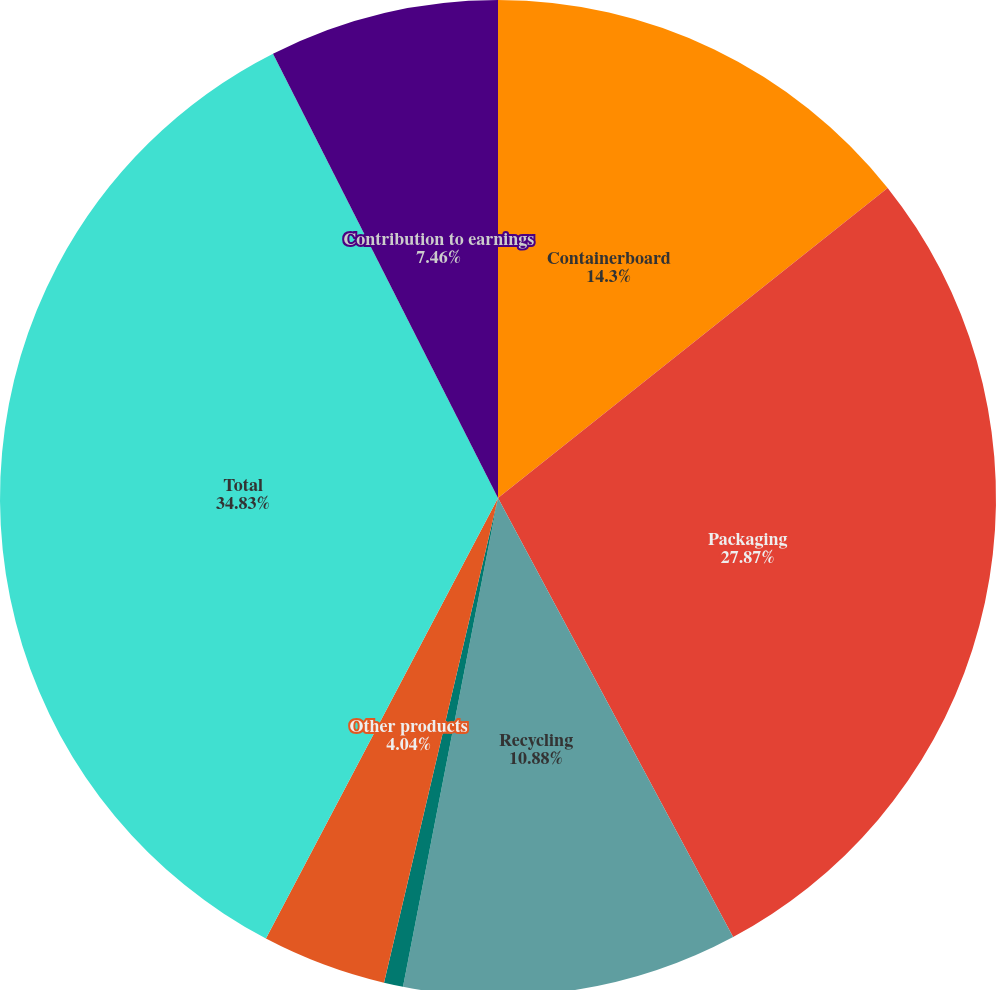<chart> <loc_0><loc_0><loc_500><loc_500><pie_chart><fcel>Containerboard<fcel>Packaging<fcel>Recycling<fcel>Kraft bags and sacks<fcel>Other products<fcel>Total<fcel>Contribution to earnings<nl><fcel>14.3%<fcel>27.87%<fcel>10.88%<fcel>0.62%<fcel>4.04%<fcel>34.82%<fcel>7.46%<nl></chart> 